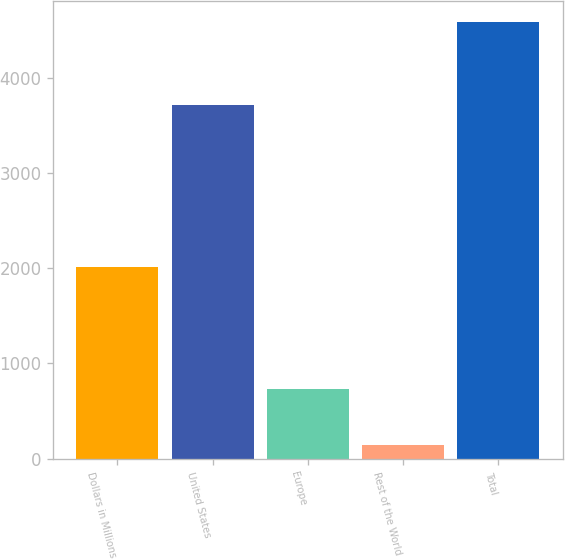Convert chart. <chart><loc_0><loc_0><loc_500><loc_500><bar_chart><fcel>Dollars in Millions<fcel>United States<fcel>Europe<fcel>Rest of the World<fcel>Total<nl><fcel>2013<fcel>3708<fcel>729<fcel>142<fcel>4579<nl></chart> 